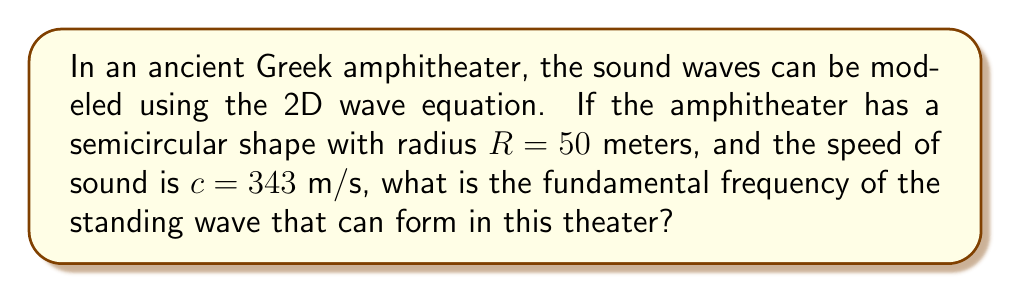Could you help me with this problem? To solve this problem, we need to follow these steps:

1. Recall the 2D wave equation in polar coordinates:

   $$\frac{\partial^2 u}{\partial t^2} = c^2 \left(\frac{\partial^2 u}{\partial r^2} + \frac{1}{r}\frac{\partial u}{\partial r} + \frac{1}{r^2}\frac{\partial^2 u}{\partial \theta^2}\right)$$

2. For a semicircular amphitheater, we can assume that the wave function $u(r,\theta,t)$ has the form:

   $$u(r,\theta,t) = R(r)\Theta(\theta)e^{i\omega t}$$

3. The boundary conditions for a semicircle are:
   - $u(R,\theta,t) = 0$ (fixed boundary at the outer edge)
   - $u(r,0,t) = u(r,\pi,t) = 0$ (fixed boundaries at the straight edges)

4. These conditions lead to the solution:

   $$u(r,\theta,t) = J_n(\frac{\omega_n r}{c})\sin(n\theta)e^{i\omega_n t}$$

   where $J_n$ is the Bessel function of the first kind of order $n$.

5. The boundary condition at $r = R$ gives:

   $$J_n(\frac{\omega_n R}{c}) = 0$$

6. The smallest non-zero solution to this equation (for $n = 1$) is:

   $$\frac{\omega_1 R}{c} \approx 3.8317$$

7. Solving for $\omega_1$:

   $$\omega_1 = \frac{3.8317c}{R}$$

8. The fundamental frequency $f_1$ is related to $\omega_1$ by:

   $$f_1 = \frac{\omega_1}{2\pi}$$

9. Substituting the given values:

   $$f_1 = \frac{3.8317 \cdot 343}{2\pi \cdot 50} \approx 4.18 \text{ Hz}$$
Answer: 4.18 Hz 